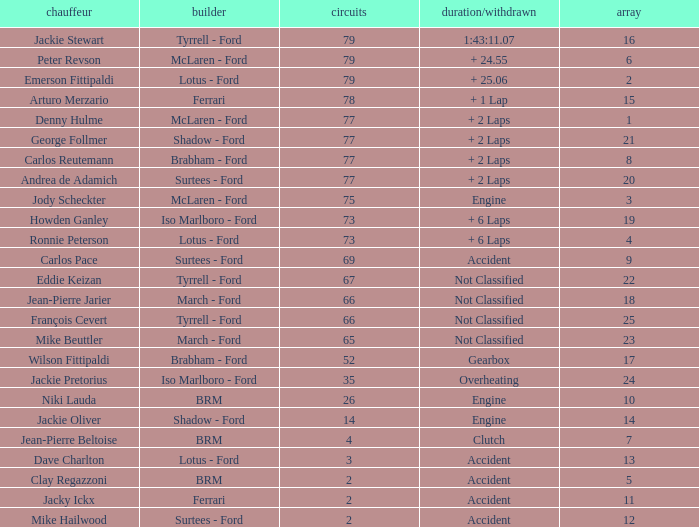What is the total grid with laps less than 2? None. 